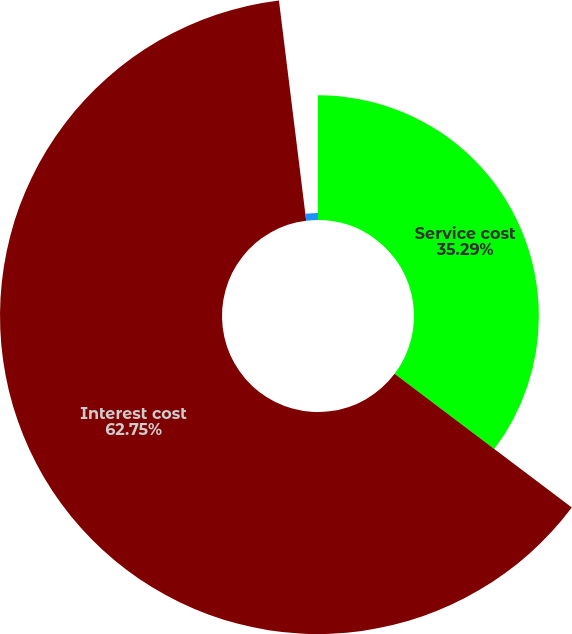Convert chart. <chart><loc_0><loc_0><loc_500><loc_500><pie_chart><fcel>Service cost<fcel>Interest cost<fcel>Amortization of prior service<nl><fcel>35.29%<fcel>62.75%<fcel>1.96%<nl></chart> 